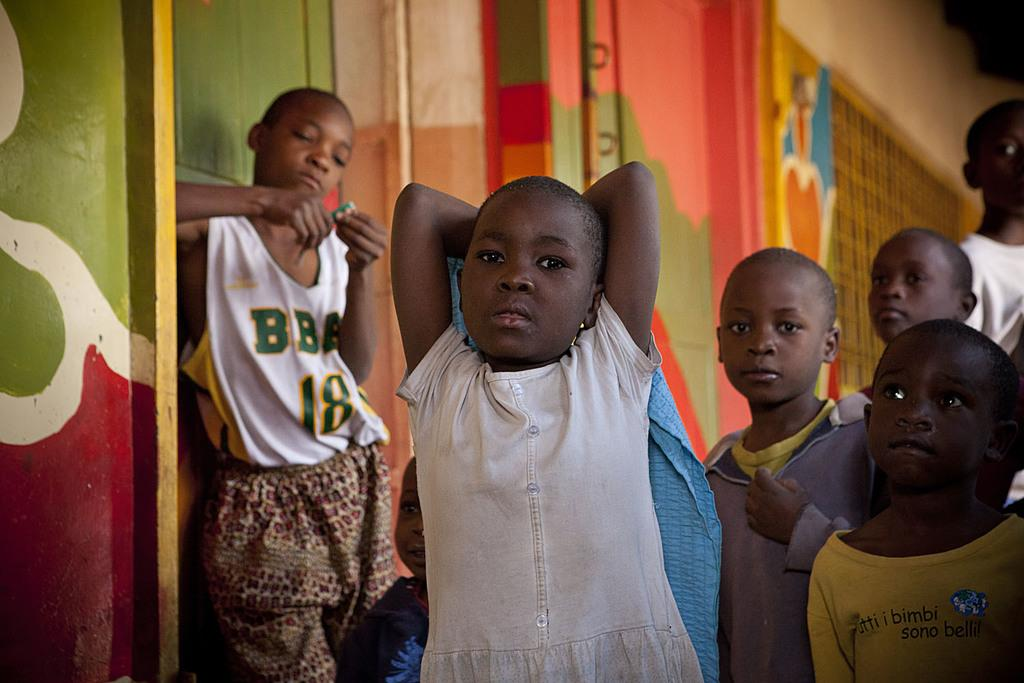What can be seen in the image? There is a group of people in the image. How are the people dressed? The people are wearing different color dresses. What is the background of the image like? There is a colorful wall in the image. How many rabbits can be seen in the image? There are no rabbits present in the image. What is the value of the dress worn by the person on the left? The value of the dress cannot be determined from the image, as it does not provide information about the cost or worth of the clothing. 